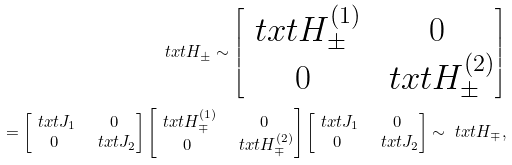Convert formula to latex. <formula><loc_0><loc_0><loc_500><loc_500>\ t x t { H } _ { \pm } \sim \begin{bmatrix} \ t x t { H } _ { \pm } ^ { ( 1 ) } & 0 \\ 0 & \ t x t { H } _ { \pm } ^ { ( 2 ) } \end{bmatrix} \\ = \begin{bmatrix} \ t x t { J } _ { 1 } & 0 \\ 0 & \ t x t { J } _ { 2 } \end{bmatrix} \begin{bmatrix} \ t x t { H } _ { \mp } ^ { ( 1 ) } & 0 \\ 0 & \ t x t { H } _ { \mp } ^ { ( 2 ) } \end{bmatrix} \begin{bmatrix} \ t x t { J } _ { 1 } & 0 \\ 0 & \ t x t { J } _ { 2 } \end{bmatrix} \sim \ t x t { H } _ { \mp } ,</formula> 